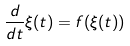Convert formula to latex. <formula><loc_0><loc_0><loc_500><loc_500>\frac { d } { d t } \xi ( t ) = f ( \xi ( t ) )</formula> 